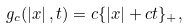<formula> <loc_0><loc_0><loc_500><loc_500>g _ { c } ( \left | x \right | , t ) = c \{ \left | x \right | + c t \} _ { + } ,</formula> 